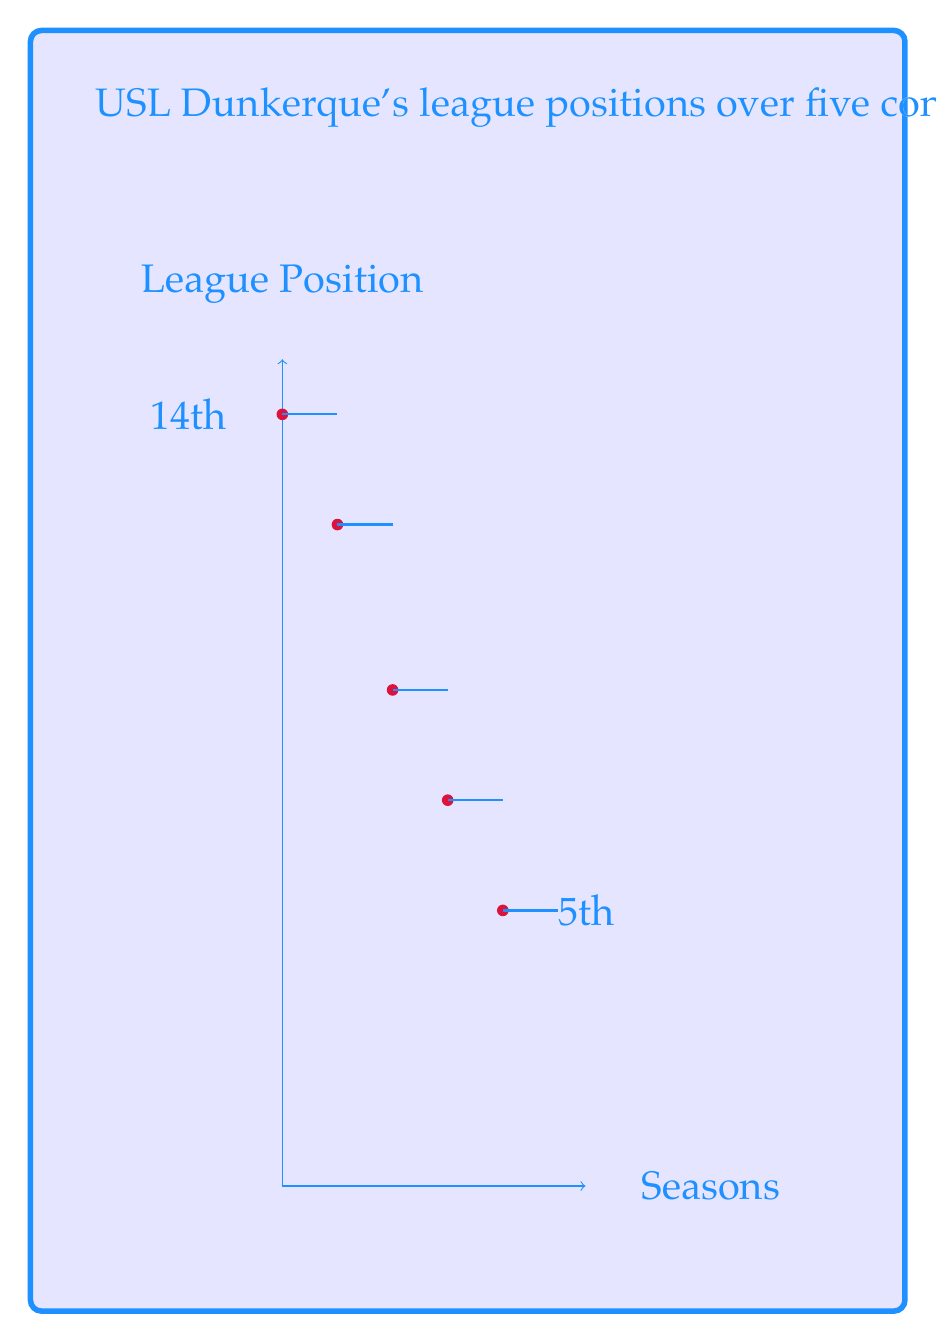Can you answer this question? To calculate the average rate of change in USL Dunkerque's league position, we need to follow these steps:

1) First, let's define our variables:
   $x$: number of seasons (starting from 0)
   $y$: league position

2) We have the following data points:
   $(0, 14)$, $(1, 12)$, $(2, 9)$, $(3, 7)$, $(4, 5)$

3) The average rate of change is given by the formula:

   $$\text{Average rate of change} = \frac{\text{Change in y}}{\text{Change in x}} = \frac{\Delta y}{\Delta x}$$

4) In this case:
   $\Delta x = 4 - 0 = 4$ (total number of seasons minus 1)
   $\Delta y = 5 - 14 = -9$ (final position minus initial position)

5) Note that $\Delta y$ is negative because the position number decreased (which indicates improvement).

6) Substituting these values into our formula:

   $$\text{Average rate of change} = \frac{-9}{4} = -2.25$$

7) The negative sign indicates that the position number is decreasing (improving) over time.
Answer: $-2.25$ positions per season 